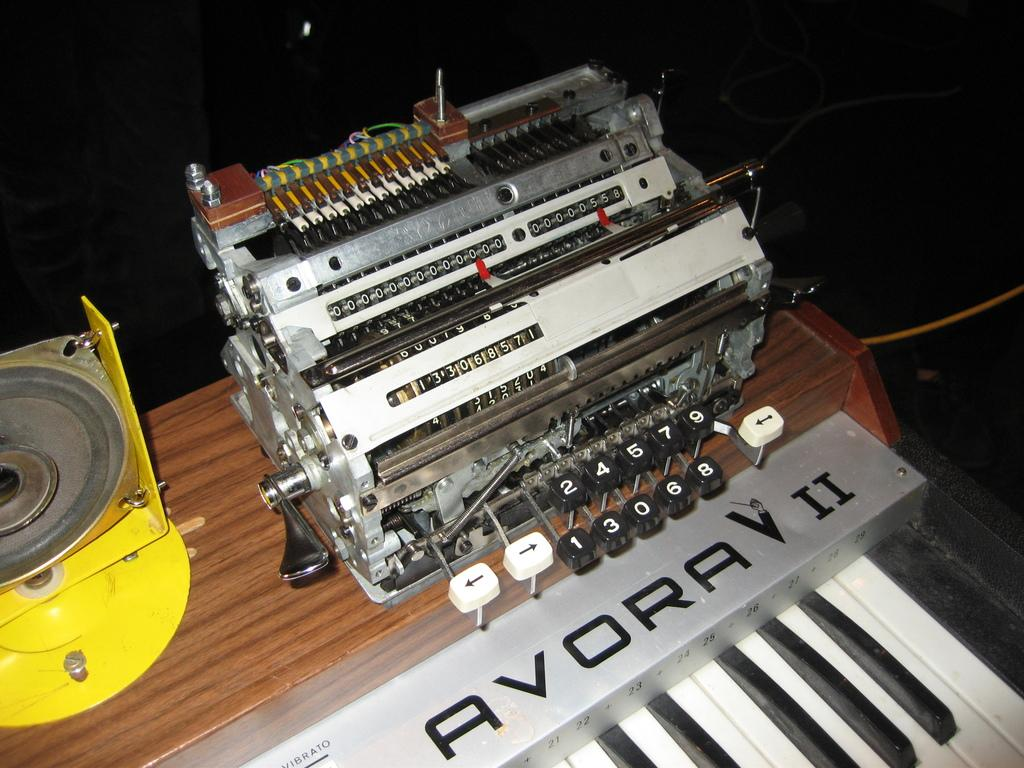What is the main object in the image? There is a typing machine in the image. What other musical instrument can be seen in the image? There is a piano in the image. How is the piano positioned in the image? The piano is on a platform. Can you describe the background of the image? The background of the image is not clear. What type of pencil is being used to play the piano in the image? There is no pencil present in the image, and the piano is not being played with a pencil. 